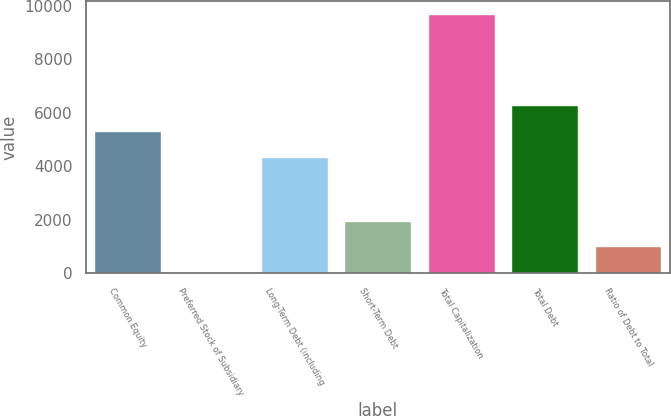Convert chart. <chart><loc_0><loc_0><loc_500><loc_500><bar_chart><fcel>Common Equity<fcel>Preferred Stock of Subsidiary<fcel>Long-Term Debt (including<fcel>Short-Term Debt<fcel>Total Capitalization<fcel>Total Debt<fcel>Ratio of Debt to Total<nl><fcel>5325.28<fcel>30.4<fcel>4360.5<fcel>1959.96<fcel>9678.2<fcel>6290.06<fcel>995.18<nl></chart> 